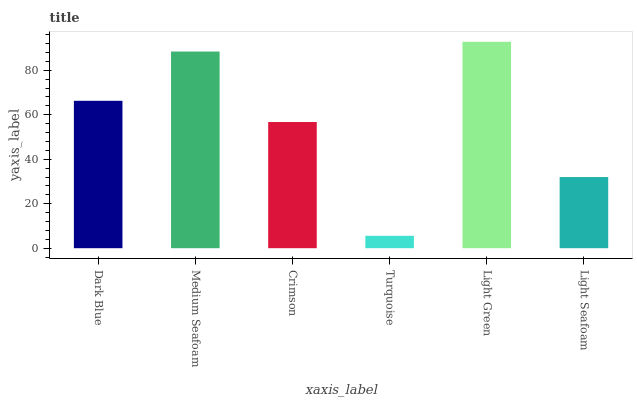Is Light Green the maximum?
Answer yes or no. Yes. Is Medium Seafoam the minimum?
Answer yes or no. No. Is Medium Seafoam the maximum?
Answer yes or no. No. Is Medium Seafoam greater than Dark Blue?
Answer yes or no. Yes. Is Dark Blue less than Medium Seafoam?
Answer yes or no. Yes. Is Dark Blue greater than Medium Seafoam?
Answer yes or no. No. Is Medium Seafoam less than Dark Blue?
Answer yes or no. No. Is Dark Blue the high median?
Answer yes or no. Yes. Is Crimson the low median?
Answer yes or no. Yes. Is Turquoise the high median?
Answer yes or no. No. Is Light Green the low median?
Answer yes or no. No. 